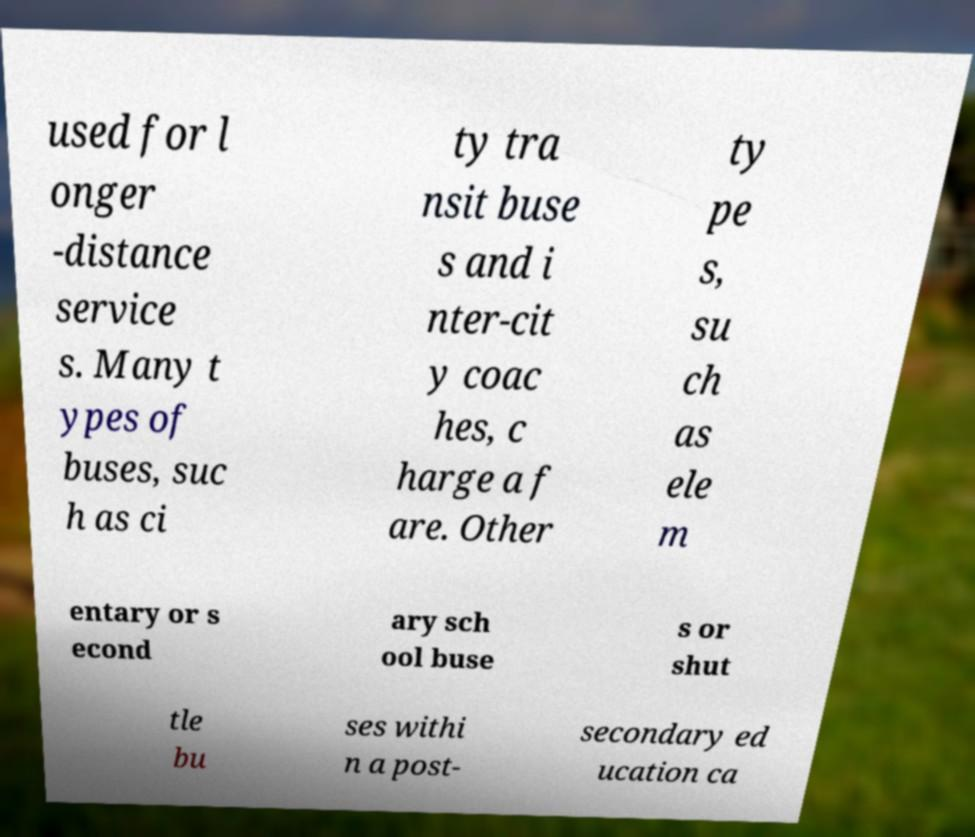I need the written content from this picture converted into text. Can you do that? used for l onger -distance service s. Many t ypes of buses, suc h as ci ty tra nsit buse s and i nter-cit y coac hes, c harge a f are. Other ty pe s, su ch as ele m entary or s econd ary sch ool buse s or shut tle bu ses withi n a post- secondary ed ucation ca 